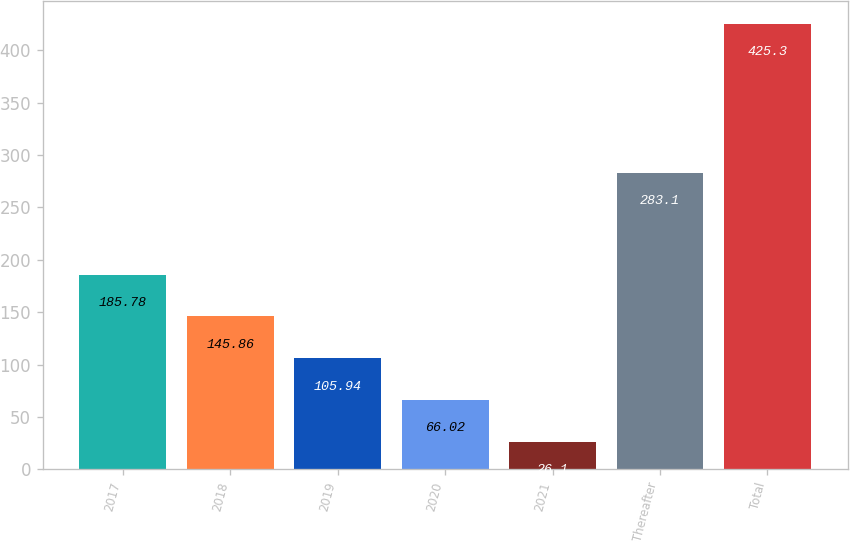Convert chart. <chart><loc_0><loc_0><loc_500><loc_500><bar_chart><fcel>2017<fcel>2018<fcel>2019<fcel>2020<fcel>2021<fcel>Thereafter<fcel>Total<nl><fcel>185.78<fcel>145.86<fcel>105.94<fcel>66.02<fcel>26.1<fcel>283.1<fcel>425.3<nl></chart> 